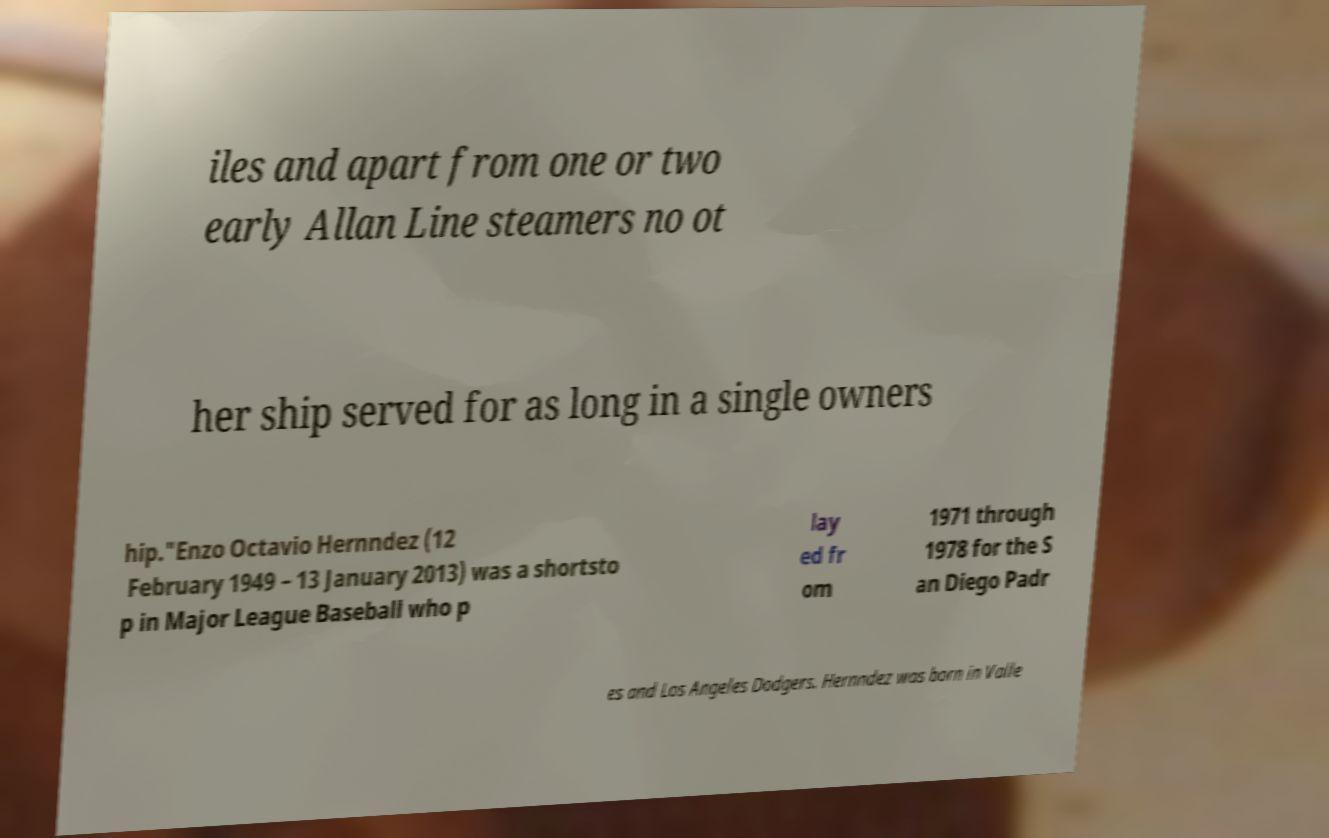There's text embedded in this image that I need extracted. Can you transcribe it verbatim? iles and apart from one or two early Allan Line steamers no ot her ship served for as long in a single owners hip."Enzo Octavio Hernndez (12 February 1949 – 13 January 2013) was a shortsto p in Major League Baseball who p lay ed fr om 1971 through 1978 for the S an Diego Padr es and Los Angeles Dodgers. Hernndez was born in Valle 